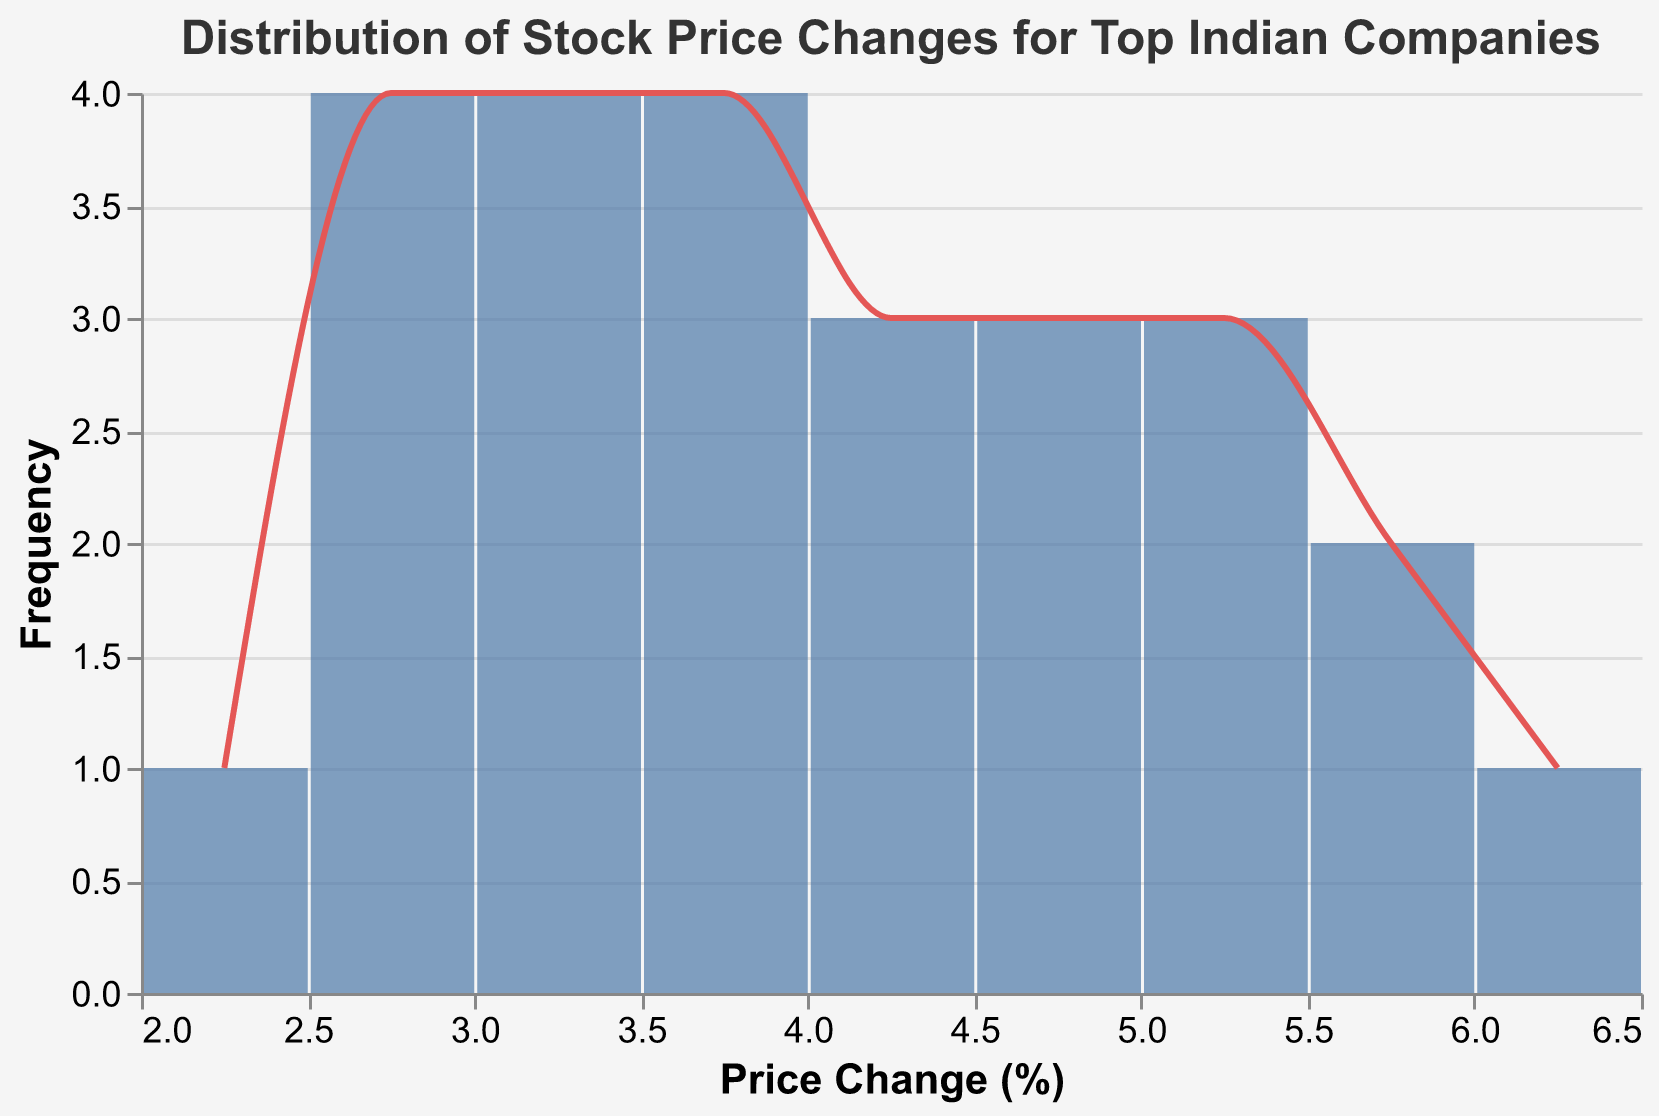What is the title of the figure? The title of the figure is usually found at the top and is the most prominent text. Here, it is described in the code.
Answer: Distribution of Stock Price Changes for Top Indian Companies What does the x-axis represent? The x-axis represents the "Price Change (%)" as it's labeled with "Price Change (%)" and shows the bins of percentage change in stock prices.
Answer: Price Change (%) How many data points fall within the bin of 2.5% to 3% price change? The y-axis represents the frequency. By observing the height of the bar for the bin of 2.5% to 3%, we can count the number of data points.
Answer: 4 What's the most frequent range of stock price change? The most frequent range is where the tallest bar is situated in the histogram.
Answer: 3.5% to 4% What's the least frequent range of stock price change? The least frequent range will have the shortest bar visible in the plot.
Answer: 2% to 2.5% How many companies experienced more than 5% price change? Sum the frequencies of the bins for price changes greater than 5%, i.e., the bins for 5% to 5.5%, 5.5% to 6%, and 6% to 6.5%, based on the plot.
Answer: 4 What is the range of the stock price change for the majority of the companies? A majority of companies would be those that fall in the bins with the highest frequencies. By examining the plot, the bins from 3% to 5% contain most of the data points.
Answer: 3% to 5% Which company had the highest price change, and how much was it? To determine the company with the highest price change, we need to look at the provided data and identify the maximum value.
Answer: ICICI Bank, 6.2% Does any company have a price change between 6% and 6.5%? Observing the tallest bar in the bin for 6% to 6.5% on the histogram, and the data point of the company ICICI Bank is present in this range.
Answer: Yes Which companies fall in the range of 3.5% to 4% price change? Identify the companies whose price changes are within the range of 3.5% to 4% from the provided data.
Answer: Kotak Mahindra Bank, UltraTech Cement, Hero MotoCorp 